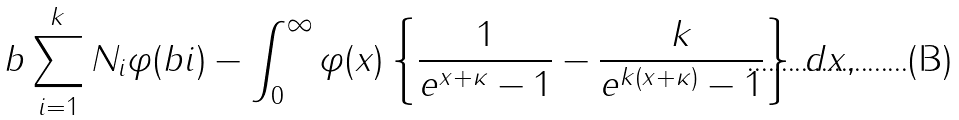<formula> <loc_0><loc_0><loc_500><loc_500>b \sum _ { i = 1 } ^ { k } N _ { i } \varphi ( b i ) - \int _ { 0 } ^ { \infty } \varphi ( x ) \left \{ \frac { 1 } { e ^ { x + \kappa } - 1 } - \frac { k } { e ^ { k ( x + \kappa ) } - 1 } \right \} \, d x ,</formula> 